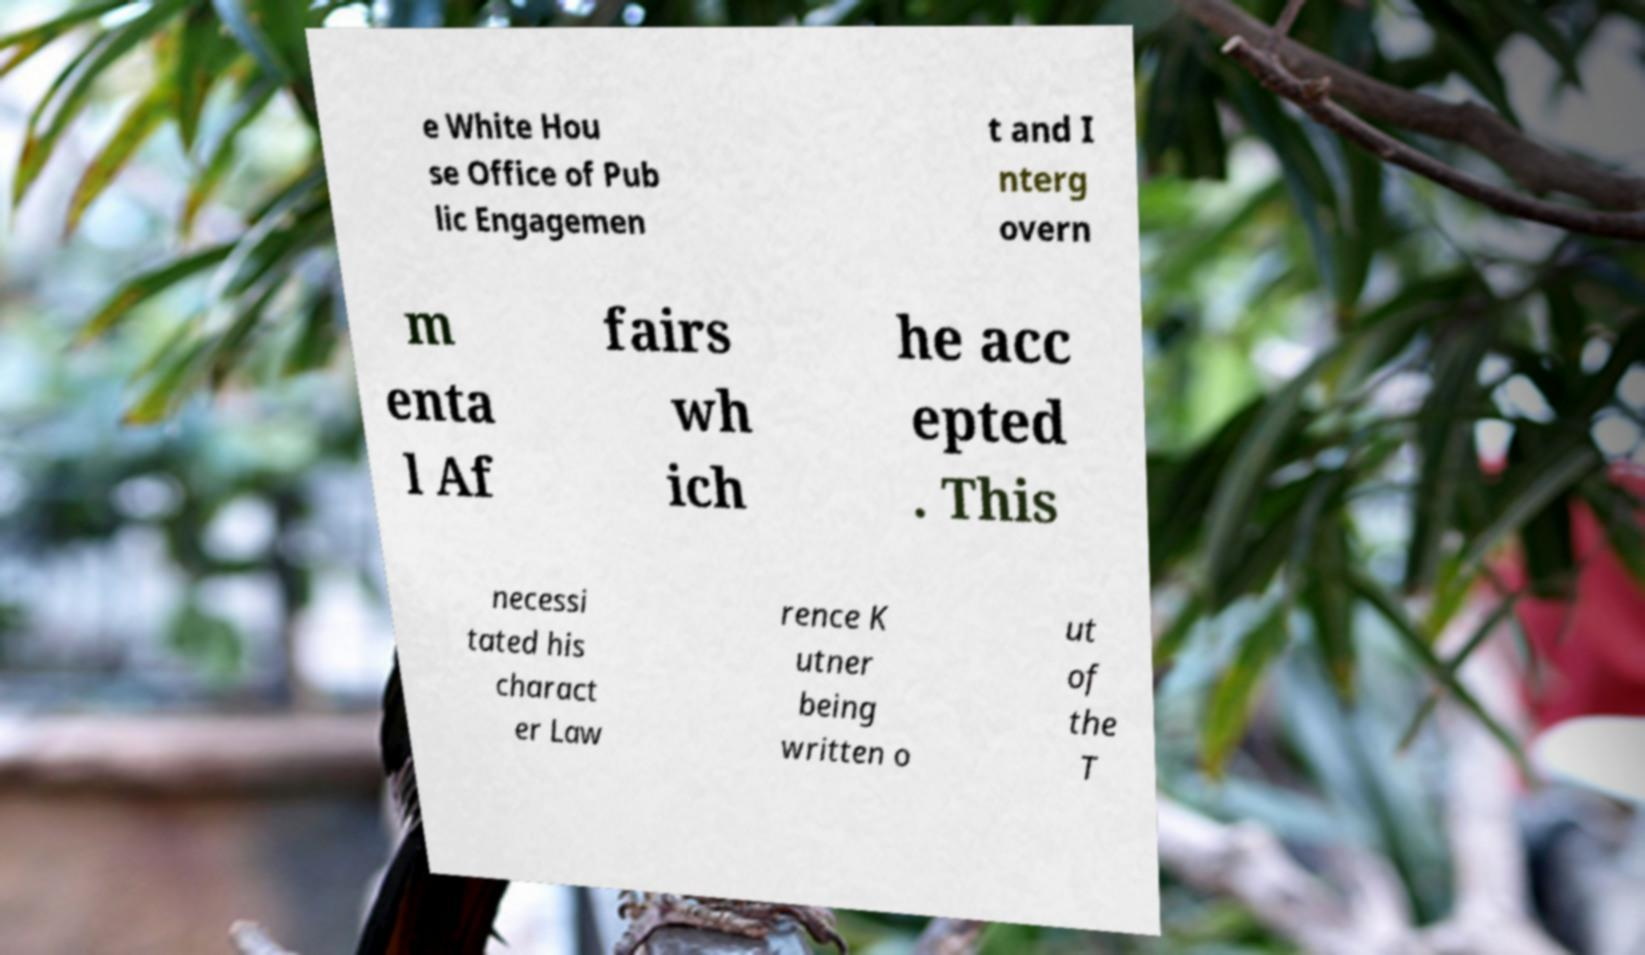Please identify and transcribe the text found in this image. e White Hou se Office of Pub lic Engagemen t and I nterg overn m enta l Af fairs wh ich he acc epted . This necessi tated his charact er Law rence K utner being written o ut of the T 